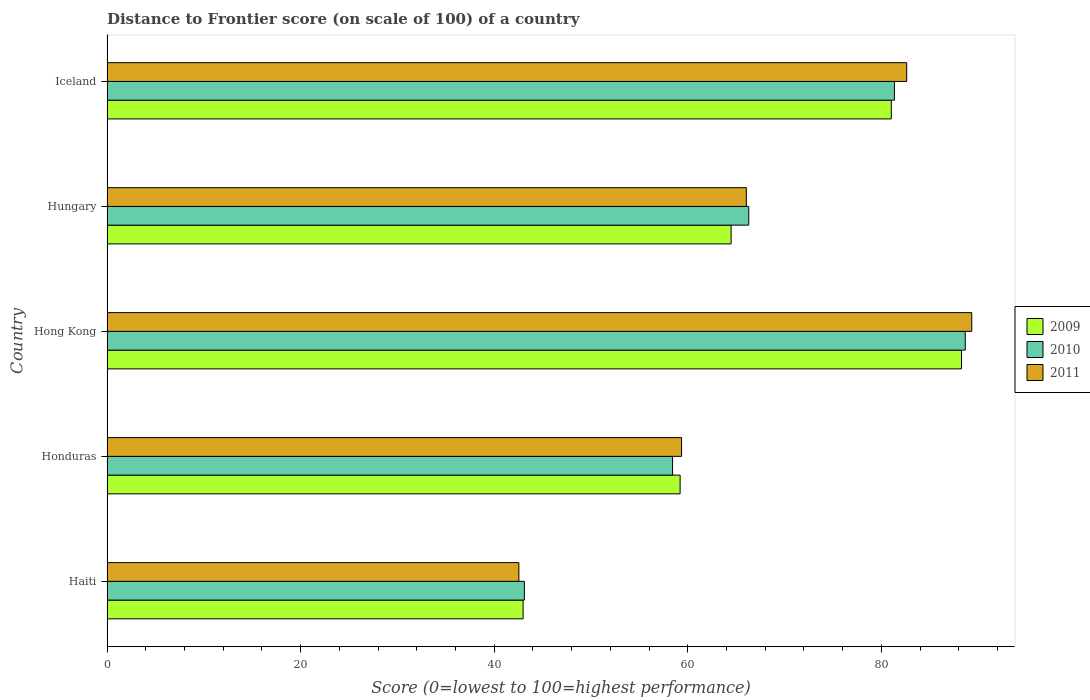How many different coloured bars are there?
Keep it short and to the point. 3. How many bars are there on the 2nd tick from the top?
Offer a terse response. 3. How many bars are there on the 3rd tick from the bottom?
Offer a terse response. 3. What is the label of the 4th group of bars from the top?
Provide a short and direct response. Honduras. What is the distance to frontier score of in 2009 in Hong Kong?
Offer a very short reply. 88.28. Across all countries, what is the maximum distance to frontier score of in 2010?
Offer a terse response. 88.67. Across all countries, what is the minimum distance to frontier score of in 2009?
Your response must be concise. 42.99. In which country was the distance to frontier score of in 2011 maximum?
Your response must be concise. Hong Kong. In which country was the distance to frontier score of in 2011 minimum?
Ensure brevity in your answer.  Haiti. What is the total distance to frontier score of in 2009 in the graph?
Provide a succinct answer. 335.99. What is the difference between the distance to frontier score of in 2010 in Honduras and that in Hungary?
Make the answer very short. -7.87. What is the difference between the distance to frontier score of in 2011 in Hong Kong and the distance to frontier score of in 2009 in Haiti?
Your answer should be compact. 46.35. What is the average distance to frontier score of in 2011 per country?
Ensure brevity in your answer.  67.98. What is the difference between the distance to frontier score of in 2009 and distance to frontier score of in 2011 in Iceland?
Your response must be concise. -1.59. What is the ratio of the distance to frontier score of in 2011 in Hong Kong to that in Iceland?
Your response must be concise. 1.08. Is the distance to frontier score of in 2011 in Haiti less than that in Hong Kong?
Offer a terse response. Yes. Is the difference between the distance to frontier score of in 2009 in Honduras and Hungary greater than the difference between the distance to frontier score of in 2011 in Honduras and Hungary?
Give a very brief answer. Yes. What is the difference between the highest and the second highest distance to frontier score of in 2010?
Your answer should be very brief. 7.32. What is the difference between the highest and the lowest distance to frontier score of in 2011?
Keep it short and to the point. 46.79. In how many countries, is the distance to frontier score of in 2009 greater than the average distance to frontier score of in 2009 taken over all countries?
Your response must be concise. 2. Is the sum of the distance to frontier score of in 2010 in Haiti and Honduras greater than the maximum distance to frontier score of in 2011 across all countries?
Ensure brevity in your answer.  Yes. What does the 1st bar from the bottom in Hong Kong represents?
Your answer should be very brief. 2009. How many bars are there?
Provide a short and direct response. 15. What is the difference between two consecutive major ticks on the X-axis?
Give a very brief answer. 20. Are the values on the major ticks of X-axis written in scientific E-notation?
Provide a succinct answer. No. Does the graph contain grids?
Your response must be concise. No. How many legend labels are there?
Offer a very short reply. 3. What is the title of the graph?
Your answer should be compact. Distance to Frontier score (on scale of 100) of a country. What is the label or title of the X-axis?
Offer a very short reply. Score (0=lowest to 100=highest performance). What is the label or title of the Y-axis?
Make the answer very short. Country. What is the Score (0=lowest to 100=highest performance) of 2009 in Haiti?
Your response must be concise. 42.99. What is the Score (0=lowest to 100=highest performance) of 2010 in Haiti?
Provide a short and direct response. 43.12. What is the Score (0=lowest to 100=highest performance) in 2011 in Haiti?
Keep it short and to the point. 42.55. What is the Score (0=lowest to 100=highest performance) of 2009 in Honduras?
Give a very brief answer. 59.21. What is the Score (0=lowest to 100=highest performance) in 2010 in Honduras?
Offer a terse response. 58.43. What is the Score (0=lowest to 100=highest performance) in 2011 in Honduras?
Provide a succinct answer. 59.36. What is the Score (0=lowest to 100=highest performance) of 2009 in Hong Kong?
Give a very brief answer. 88.28. What is the Score (0=lowest to 100=highest performance) of 2010 in Hong Kong?
Provide a succinct answer. 88.67. What is the Score (0=lowest to 100=highest performance) of 2011 in Hong Kong?
Your answer should be compact. 89.34. What is the Score (0=lowest to 100=highest performance) of 2009 in Hungary?
Make the answer very short. 64.48. What is the Score (0=lowest to 100=highest performance) in 2010 in Hungary?
Your answer should be very brief. 66.3. What is the Score (0=lowest to 100=highest performance) of 2011 in Hungary?
Give a very brief answer. 66.05. What is the Score (0=lowest to 100=highest performance) in 2009 in Iceland?
Provide a succinct answer. 81.03. What is the Score (0=lowest to 100=highest performance) in 2010 in Iceland?
Your response must be concise. 81.35. What is the Score (0=lowest to 100=highest performance) in 2011 in Iceland?
Keep it short and to the point. 82.62. Across all countries, what is the maximum Score (0=lowest to 100=highest performance) of 2009?
Offer a terse response. 88.28. Across all countries, what is the maximum Score (0=lowest to 100=highest performance) of 2010?
Give a very brief answer. 88.67. Across all countries, what is the maximum Score (0=lowest to 100=highest performance) in 2011?
Offer a very short reply. 89.34. Across all countries, what is the minimum Score (0=lowest to 100=highest performance) of 2009?
Your response must be concise. 42.99. Across all countries, what is the minimum Score (0=lowest to 100=highest performance) of 2010?
Your response must be concise. 43.12. Across all countries, what is the minimum Score (0=lowest to 100=highest performance) of 2011?
Your answer should be very brief. 42.55. What is the total Score (0=lowest to 100=highest performance) of 2009 in the graph?
Your answer should be compact. 335.99. What is the total Score (0=lowest to 100=highest performance) in 2010 in the graph?
Your response must be concise. 337.87. What is the total Score (0=lowest to 100=highest performance) in 2011 in the graph?
Your answer should be very brief. 339.92. What is the difference between the Score (0=lowest to 100=highest performance) of 2009 in Haiti and that in Honduras?
Offer a terse response. -16.22. What is the difference between the Score (0=lowest to 100=highest performance) in 2010 in Haiti and that in Honduras?
Make the answer very short. -15.31. What is the difference between the Score (0=lowest to 100=highest performance) in 2011 in Haiti and that in Honduras?
Your answer should be very brief. -16.81. What is the difference between the Score (0=lowest to 100=highest performance) in 2009 in Haiti and that in Hong Kong?
Keep it short and to the point. -45.29. What is the difference between the Score (0=lowest to 100=highest performance) of 2010 in Haiti and that in Hong Kong?
Your answer should be compact. -45.55. What is the difference between the Score (0=lowest to 100=highest performance) of 2011 in Haiti and that in Hong Kong?
Provide a succinct answer. -46.79. What is the difference between the Score (0=lowest to 100=highest performance) in 2009 in Haiti and that in Hungary?
Offer a very short reply. -21.49. What is the difference between the Score (0=lowest to 100=highest performance) in 2010 in Haiti and that in Hungary?
Your answer should be compact. -23.18. What is the difference between the Score (0=lowest to 100=highest performance) of 2011 in Haiti and that in Hungary?
Provide a succinct answer. -23.5. What is the difference between the Score (0=lowest to 100=highest performance) of 2009 in Haiti and that in Iceland?
Give a very brief answer. -38.04. What is the difference between the Score (0=lowest to 100=highest performance) in 2010 in Haiti and that in Iceland?
Ensure brevity in your answer.  -38.23. What is the difference between the Score (0=lowest to 100=highest performance) in 2011 in Haiti and that in Iceland?
Make the answer very short. -40.07. What is the difference between the Score (0=lowest to 100=highest performance) in 2009 in Honduras and that in Hong Kong?
Provide a short and direct response. -29.07. What is the difference between the Score (0=lowest to 100=highest performance) in 2010 in Honduras and that in Hong Kong?
Your answer should be compact. -30.24. What is the difference between the Score (0=lowest to 100=highest performance) of 2011 in Honduras and that in Hong Kong?
Offer a very short reply. -29.98. What is the difference between the Score (0=lowest to 100=highest performance) in 2009 in Honduras and that in Hungary?
Provide a short and direct response. -5.27. What is the difference between the Score (0=lowest to 100=highest performance) in 2010 in Honduras and that in Hungary?
Your response must be concise. -7.87. What is the difference between the Score (0=lowest to 100=highest performance) in 2011 in Honduras and that in Hungary?
Provide a succinct answer. -6.69. What is the difference between the Score (0=lowest to 100=highest performance) in 2009 in Honduras and that in Iceland?
Ensure brevity in your answer.  -21.82. What is the difference between the Score (0=lowest to 100=highest performance) of 2010 in Honduras and that in Iceland?
Offer a terse response. -22.92. What is the difference between the Score (0=lowest to 100=highest performance) of 2011 in Honduras and that in Iceland?
Make the answer very short. -23.26. What is the difference between the Score (0=lowest to 100=highest performance) in 2009 in Hong Kong and that in Hungary?
Your answer should be very brief. 23.8. What is the difference between the Score (0=lowest to 100=highest performance) of 2010 in Hong Kong and that in Hungary?
Your answer should be compact. 22.37. What is the difference between the Score (0=lowest to 100=highest performance) of 2011 in Hong Kong and that in Hungary?
Your answer should be very brief. 23.29. What is the difference between the Score (0=lowest to 100=highest performance) of 2009 in Hong Kong and that in Iceland?
Offer a terse response. 7.25. What is the difference between the Score (0=lowest to 100=highest performance) of 2010 in Hong Kong and that in Iceland?
Offer a terse response. 7.32. What is the difference between the Score (0=lowest to 100=highest performance) in 2011 in Hong Kong and that in Iceland?
Give a very brief answer. 6.72. What is the difference between the Score (0=lowest to 100=highest performance) of 2009 in Hungary and that in Iceland?
Your answer should be very brief. -16.55. What is the difference between the Score (0=lowest to 100=highest performance) of 2010 in Hungary and that in Iceland?
Offer a terse response. -15.05. What is the difference between the Score (0=lowest to 100=highest performance) of 2011 in Hungary and that in Iceland?
Your answer should be compact. -16.57. What is the difference between the Score (0=lowest to 100=highest performance) of 2009 in Haiti and the Score (0=lowest to 100=highest performance) of 2010 in Honduras?
Ensure brevity in your answer.  -15.44. What is the difference between the Score (0=lowest to 100=highest performance) in 2009 in Haiti and the Score (0=lowest to 100=highest performance) in 2011 in Honduras?
Your answer should be very brief. -16.37. What is the difference between the Score (0=lowest to 100=highest performance) in 2010 in Haiti and the Score (0=lowest to 100=highest performance) in 2011 in Honduras?
Offer a very short reply. -16.24. What is the difference between the Score (0=lowest to 100=highest performance) of 2009 in Haiti and the Score (0=lowest to 100=highest performance) of 2010 in Hong Kong?
Offer a very short reply. -45.68. What is the difference between the Score (0=lowest to 100=highest performance) in 2009 in Haiti and the Score (0=lowest to 100=highest performance) in 2011 in Hong Kong?
Your answer should be compact. -46.35. What is the difference between the Score (0=lowest to 100=highest performance) in 2010 in Haiti and the Score (0=lowest to 100=highest performance) in 2011 in Hong Kong?
Provide a short and direct response. -46.22. What is the difference between the Score (0=lowest to 100=highest performance) of 2009 in Haiti and the Score (0=lowest to 100=highest performance) of 2010 in Hungary?
Offer a terse response. -23.31. What is the difference between the Score (0=lowest to 100=highest performance) in 2009 in Haiti and the Score (0=lowest to 100=highest performance) in 2011 in Hungary?
Your response must be concise. -23.06. What is the difference between the Score (0=lowest to 100=highest performance) in 2010 in Haiti and the Score (0=lowest to 100=highest performance) in 2011 in Hungary?
Give a very brief answer. -22.93. What is the difference between the Score (0=lowest to 100=highest performance) of 2009 in Haiti and the Score (0=lowest to 100=highest performance) of 2010 in Iceland?
Ensure brevity in your answer.  -38.36. What is the difference between the Score (0=lowest to 100=highest performance) in 2009 in Haiti and the Score (0=lowest to 100=highest performance) in 2011 in Iceland?
Make the answer very short. -39.63. What is the difference between the Score (0=lowest to 100=highest performance) of 2010 in Haiti and the Score (0=lowest to 100=highest performance) of 2011 in Iceland?
Provide a succinct answer. -39.5. What is the difference between the Score (0=lowest to 100=highest performance) of 2009 in Honduras and the Score (0=lowest to 100=highest performance) of 2010 in Hong Kong?
Keep it short and to the point. -29.46. What is the difference between the Score (0=lowest to 100=highest performance) of 2009 in Honduras and the Score (0=lowest to 100=highest performance) of 2011 in Hong Kong?
Your answer should be very brief. -30.13. What is the difference between the Score (0=lowest to 100=highest performance) in 2010 in Honduras and the Score (0=lowest to 100=highest performance) in 2011 in Hong Kong?
Your answer should be very brief. -30.91. What is the difference between the Score (0=lowest to 100=highest performance) of 2009 in Honduras and the Score (0=lowest to 100=highest performance) of 2010 in Hungary?
Your response must be concise. -7.09. What is the difference between the Score (0=lowest to 100=highest performance) in 2009 in Honduras and the Score (0=lowest to 100=highest performance) in 2011 in Hungary?
Provide a short and direct response. -6.84. What is the difference between the Score (0=lowest to 100=highest performance) in 2010 in Honduras and the Score (0=lowest to 100=highest performance) in 2011 in Hungary?
Provide a succinct answer. -7.62. What is the difference between the Score (0=lowest to 100=highest performance) of 2009 in Honduras and the Score (0=lowest to 100=highest performance) of 2010 in Iceland?
Make the answer very short. -22.14. What is the difference between the Score (0=lowest to 100=highest performance) of 2009 in Honduras and the Score (0=lowest to 100=highest performance) of 2011 in Iceland?
Keep it short and to the point. -23.41. What is the difference between the Score (0=lowest to 100=highest performance) of 2010 in Honduras and the Score (0=lowest to 100=highest performance) of 2011 in Iceland?
Your response must be concise. -24.19. What is the difference between the Score (0=lowest to 100=highest performance) in 2009 in Hong Kong and the Score (0=lowest to 100=highest performance) in 2010 in Hungary?
Provide a short and direct response. 21.98. What is the difference between the Score (0=lowest to 100=highest performance) in 2009 in Hong Kong and the Score (0=lowest to 100=highest performance) in 2011 in Hungary?
Your response must be concise. 22.23. What is the difference between the Score (0=lowest to 100=highest performance) in 2010 in Hong Kong and the Score (0=lowest to 100=highest performance) in 2011 in Hungary?
Offer a very short reply. 22.62. What is the difference between the Score (0=lowest to 100=highest performance) in 2009 in Hong Kong and the Score (0=lowest to 100=highest performance) in 2010 in Iceland?
Give a very brief answer. 6.93. What is the difference between the Score (0=lowest to 100=highest performance) of 2009 in Hong Kong and the Score (0=lowest to 100=highest performance) of 2011 in Iceland?
Give a very brief answer. 5.66. What is the difference between the Score (0=lowest to 100=highest performance) of 2010 in Hong Kong and the Score (0=lowest to 100=highest performance) of 2011 in Iceland?
Make the answer very short. 6.05. What is the difference between the Score (0=lowest to 100=highest performance) of 2009 in Hungary and the Score (0=lowest to 100=highest performance) of 2010 in Iceland?
Offer a terse response. -16.87. What is the difference between the Score (0=lowest to 100=highest performance) in 2009 in Hungary and the Score (0=lowest to 100=highest performance) in 2011 in Iceland?
Your response must be concise. -18.14. What is the difference between the Score (0=lowest to 100=highest performance) in 2010 in Hungary and the Score (0=lowest to 100=highest performance) in 2011 in Iceland?
Give a very brief answer. -16.32. What is the average Score (0=lowest to 100=highest performance) in 2009 per country?
Make the answer very short. 67.2. What is the average Score (0=lowest to 100=highest performance) of 2010 per country?
Provide a succinct answer. 67.57. What is the average Score (0=lowest to 100=highest performance) of 2011 per country?
Offer a very short reply. 67.98. What is the difference between the Score (0=lowest to 100=highest performance) in 2009 and Score (0=lowest to 100=highest performance) in 2010 in Haiti?
Give a very brief answer. -0.13. What is the difference between the Score (0=lowest to 100=highest performance) in 2009 and Score (0=lowest to 100=highest performance) in 2011 in Haiti?
Your answer should be compact. 0.44. What is the difference between the Score (0=lowest to 100=highest performance) in 2010 and Score (0=lowest to 100=highest performance) in 2011 in Haiti?
Your answer should be compact. 0.57. What is the difference between the Score (0=lowest to 100=highest performance) of 2009 and Score (0=lowest to 100=highest performance) of 2010 in Honduras?
Ensure brevity in your answer.  0.78. What is the difference between the Score (0=lowest to 100=highest performance) in 2009 and Score (0=lowest to 100=highest performance) in 2011 in Honduras?
Keep it short and to the point. -0.15. What is the difference between the Score (0=lowest to 100=highest performance) of 2010 and Score (0=lowest to 100=highest performance) of 2011 in Honduras?
Your answer should be very brief. -0.93. What is the difference between the Score (0=lowest to 100=highest performance) in 2009 and Score (0=lowest to 100=highest performance) in 2010 in Hong Kong?
Your answer should be very brief. -0.39. What is the difference between the Score (0=lowest to 100=highest performance) of 2009 and Score (0=lowest to 100=highest performance) of 2011 in Hong Kong?
Keep it short and to the point. -1.06. What is the difference between the Score (0=lowest to 100=highest performance) in 2010 and Score (0=lowest to 100=highest performance) in 2011 in Hong Kong?
Your answer should be very brief. -0.67. What is the difference between the Score (0=lowest to 100=highest performance) of 2009 and Score (0=lowest to 100=highest performance) of 2010 in Hungary?
Provide a succinct answer. -1.82. What is the difference between the Score (0=lowest to 100=highest performance) in 2009 and Score (0=lowest to 100=highest performance) in 2011 in Hungary?
Offer a terse response. -1.57. What is the difference between the Score (0=lowest to 100=highest performance) of 2009 and Score (0=lowest to 100=highest performance) of 2010 in Iceland?
Your answer should be very brief. -0.32. What is the difference between the Score (0=lowest to 100=highest performance) of 2009 and Score (0=lowest to 100=highest performance) of 2011 in Iceland?
Provide a succinct answer. -1.59. What is the difference between the Score (0=lowest to 100=highest performance) of 2010 and Score (0=lowest to 100=highest performance) of 2011 in Iceland?
Your answer should be compact. -1.27. What is the ratio of the Score (0=lowest to 100=highest performance) in 2009 in Haiti to that in Honduras?
Your response must be concise. 0.73. What is the ratio of the Score (0=lowest to 100=highest performance) of 2010 in Haiti to that in Honduras?
Provide a short and direct response. 0.74. What is the ratio of the Score (0=lowest to 100=highest performance) in 2011 in Haiti to that in Honduras?
Offer a very short reply. 0.72. What is the ratio of the Score (0=lowest to 100=highest performance) of 2009 in Haiti to that in Hong Kong?
Your response must be concise. 0.49. What is the ratio of the Score (0=lowest to 100=highest performance) in 2010 in Haiti to that in Hong Kong?
Offer a terse response. 0.49. What is the ratio of the Score (0=lowest to 100=highest performance) in 2011 in Haiti to that in Hong Kong?
Offer a terse response. 0.48. What is the ratio of the Score (0=lowest to 100=highest performance) of 2009 in Haiti to that in Hungary?
Your answer should be very brief. 0.67. What is the ratio of the Score (0=lowest to 100=highest performance) in 2010 in Haiti to that in Hungary?
Your answer should be very brief. 0.65. What is the ratio of the Score (0=lowest to 100=highest performance) of 2011 in Haiti to that in Hungary?
Offer a very short reply. 0.64. What is the ratio of the Score (0=lowest to 100=highest performance) in 2009 in Haiti to that in Iceland?
Make the answer very short. 0.53. What is the ratio of the Score (0=lowest to 100=highest performance) in 2010 in Haiti to that in Iceland?
Your answer should be very brief. 0.53. What is the ratio of the Score (0=lowest to 100=highest performance) in 2011 in Haiti to that in Iceland?
Make the answer very short. 0.52. What is the ratio of the Score (0=lowest to 100=highest performance) in 2009 in Honduras to that in Hong Kong?
Your answer should be very brief. 0.67. What is the ratio of the Score (0=lowest to 100=highest performance) of 2010 in Honduras to that in Hong Kong?
Your response must be concise. 0.66. What is the ratio of the Score (0=lowest to 100=highest performance) in 2011 in Honduras to that in Hong Kong?
Offer a very short reply. 0.66. What is the ratio of the Score (0=lowest to 100=highest performance) of 2009 in Honduras to that in Hungary?
Your response must be concise. 0.92. What is the ratio of the Score (0=lowest to 100=highest performance) of 2010 in Honduras to that in Hungary?
Offer a terse response. 0.88. What is the ratio of the Score (0=lowest to 100=highest performance) in 2011 in Honduras to that in Hungary?
Keep it short and to the point. 0.9. What is the ratio of the Score (0=lowest to 100=highest performance) of 2009 in Honduras to that in Iceland?
Offer a terse response. 0.73. What is the ratio of the Score (0=lowest to 100=highest performance) in 2010 in Honduras to that in Iceland?
Your answer should be very brief. 0.72. What is the ratio of the Score (0=lowest to 100=highest performance) in 2011 in Honduras to that in Iceland?
Ensure brevity in your answer.  0.72. What is the ratio of the Score (0=lowest to 100=highest performance) of 2009 in Hong Kong to that in Hungary?
Your answer should be very brief. 1.37. What is the ratio of the Score (0=lowest to 100=highest performance) in 2010 in Hong Kong to that in Hungary?
Ensure brevity in your answer.  1.34. What is the ratio of the Score (0=lowest to 100=highest performance) in 2011 in Hong Kong to that in Hungary?
Give a very brief answer. 1.35. What is the ratio of the Score (0=lowest to 100=highest performance) of 2009 in Hong Kong to that in Iceland?
Your answer should be compact. 1.09. What is the ratio of the Score (0=lowest to 100=highest performance) of 2010 in Hong Kong to that in Iceland?
Give a very brief answer. 1.09. What is the ratio of the Score (0=lowest to 100=highest performance) of 2011 in Hong Kong to that in Iceland?
Provide a succinct answer. 1.08. What is the ratio of the Score (0=lowest to 100=highest performance) of 2009 in Hungary to that in Iceland?
Your response must be concise. 0.8. What is the ratio of the Score (0=lowest to 100=highest performance) in 2010 in Hungary to that in Iceland?
Offer a very short reply. 0.81. What is the ratio of the Score (0=lowest to 100=highest performance) in 2011 in Hungary to that in Iceland?
Keep it short and to the point. 0.8. What is the difference between the highest and the second highest Score (0=lowest to 100=highest performance) in 2009?
Offer a terse response. 7.25. What is the difference between the highest and the second highest Score (0=lowest to 100=highest performance) of 2010?
Offer a terse response. 7.32. What is the difference between the highest and the second highest Score (0=lowest to 100=highest performance) of 2011?
Offer a very short reply. 6.72. What is the difference between the highest and the lowest Score (0=lowest to 100=highest performance) in 2009?
Provide a succinct answer. 45.29. What is the difference between the highest and the lowest Score (0=lowest to 100=highest performance) in 2010?
Give a very brief answer. 45.55. What is the difference between the highest and the lowest Score (0=lowest to 100=highest performance) in 2011?
Your answer should be compact. 46.79. 